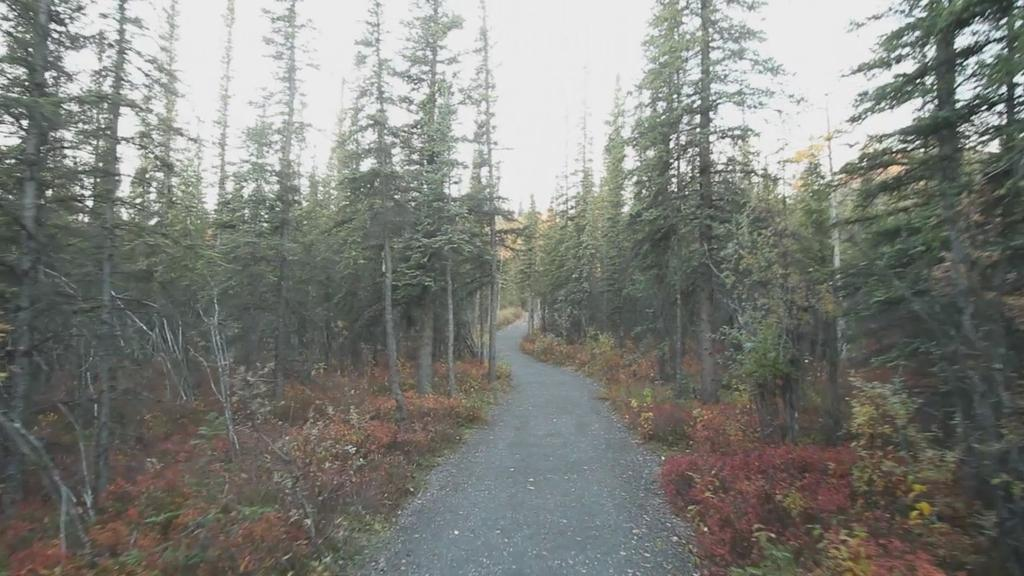What is the main feature of the image? There is a road in the image. What can be seen around the road? There are trees around the road. What type of vegetation is present in the image? There are plants in the image. What is covering the ground in the image? There is grass on the floor in the image. What color is the wool on the road in the image? There is no wool present on the road in the image. What does the mom say about the plants in the image? There is no mom present in the image, so we cannot determine what she might say about the plants. 